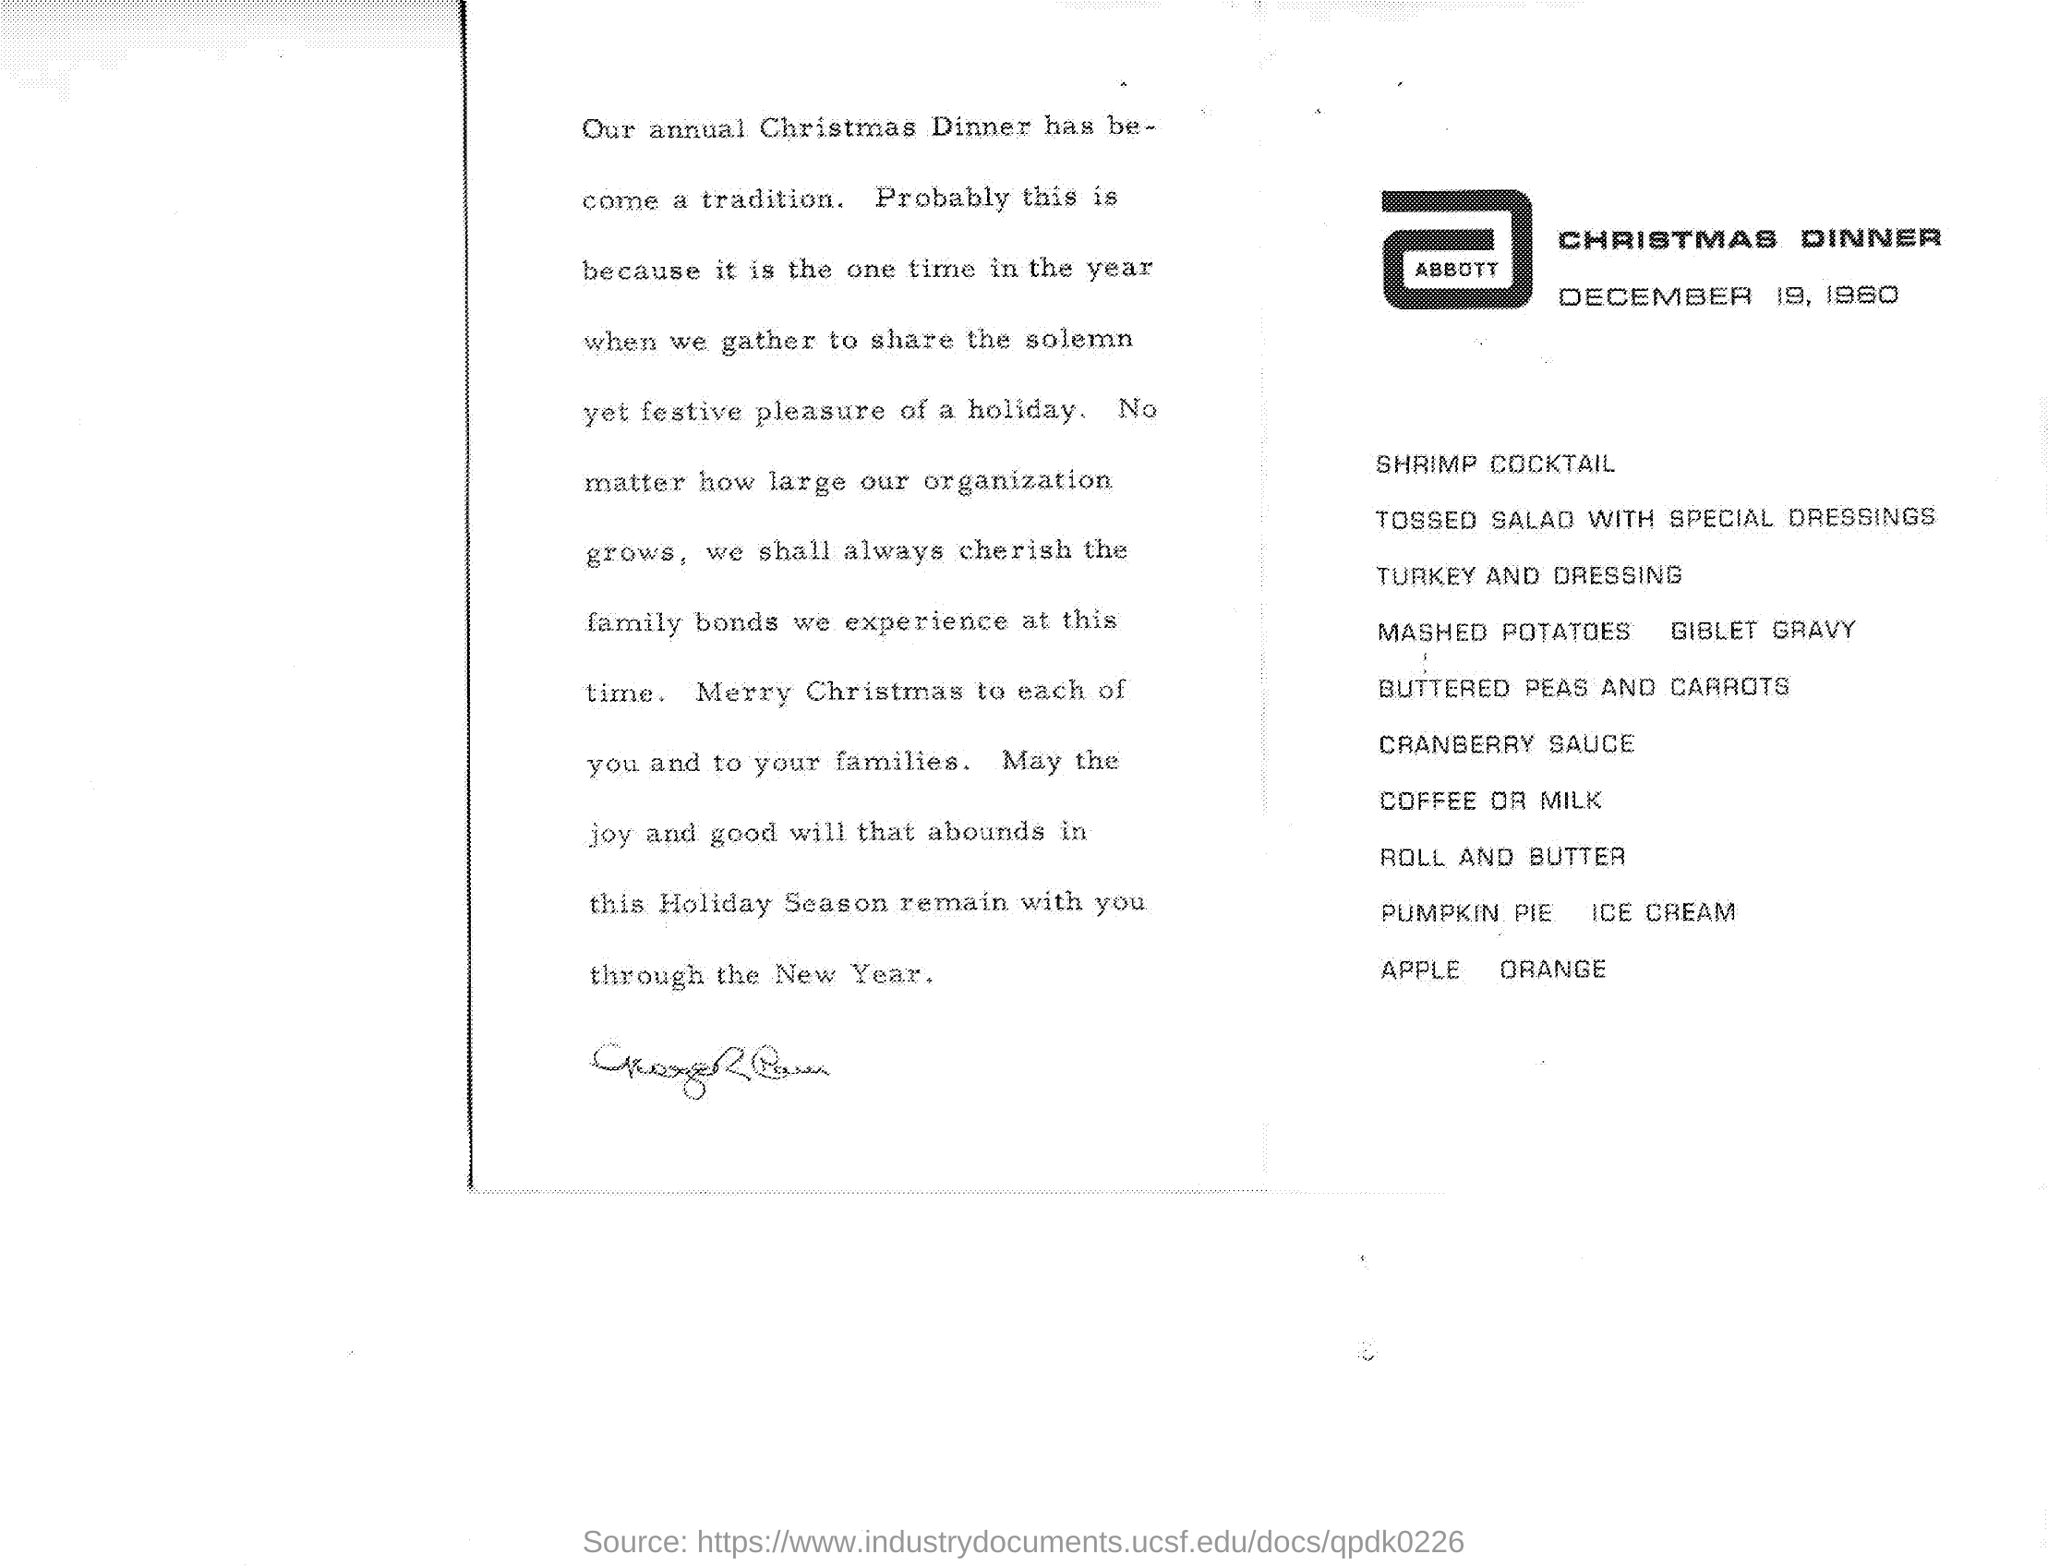Outline some significant characteristics in this image. On December 19, 1960, Christmas Dinner will take place. 